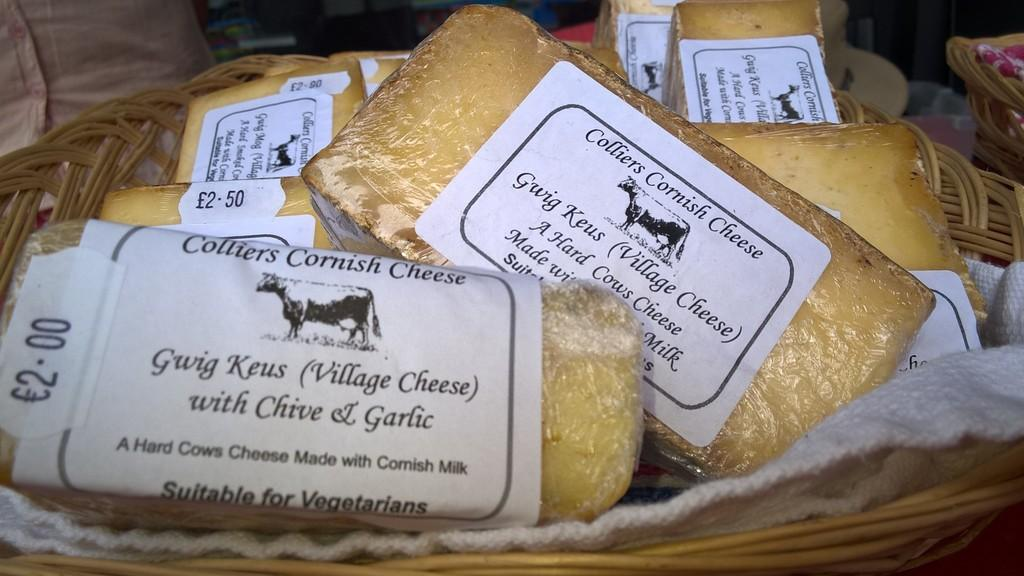What type of containers are visible in the image? There are wooden baskets in the image. What is inside the wooden baskets? The baskets contain food items. How are the food items protected or covered? The food items are wrapped in plastic covers. How can the food items be identified? There are labels on the food items with text on them. What additional design element is present on the labels? The labels have a symbol of an animal on them. Where is the throne located in the image? There is no throne present in the image. What type of drum can be seen in the image? There is no drum present in the image. 